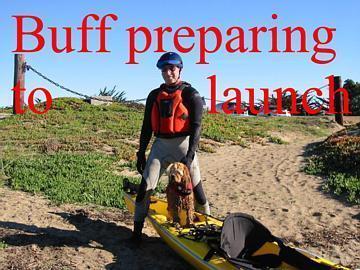How many kayaks are in the picture?
Give a very brief answer. 1. 